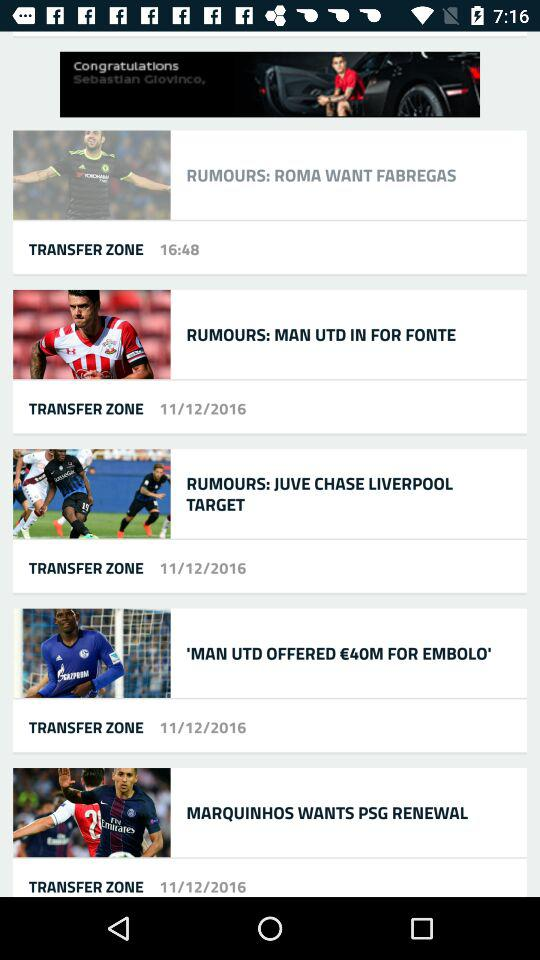What is the time? The time is 16:48. 